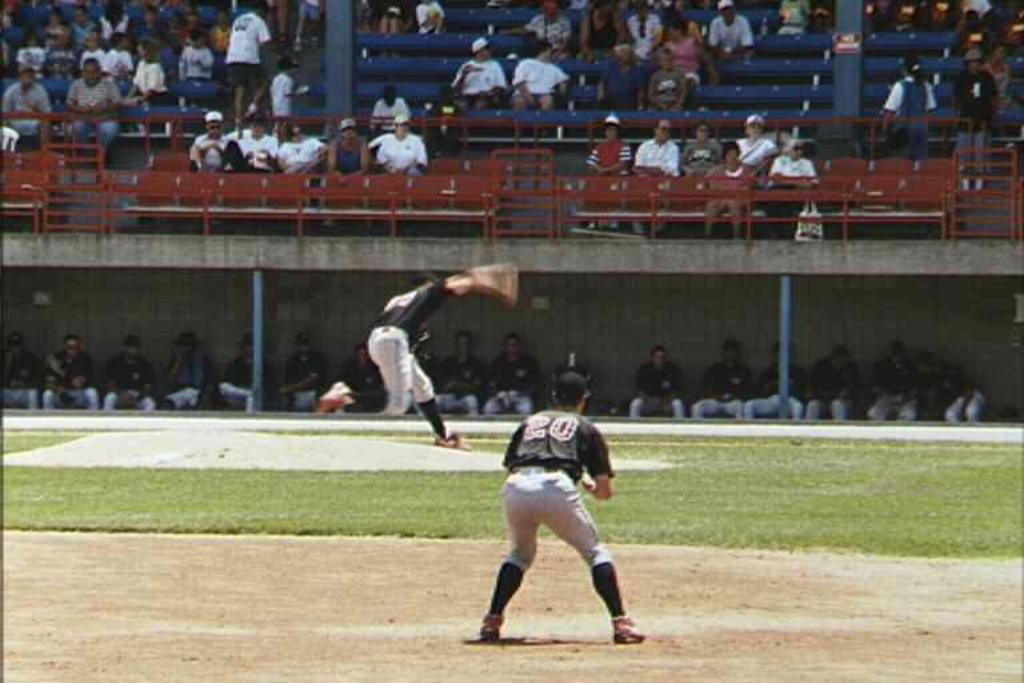<image>
Offer a succinct explanation of the picture presented. A man in a 20 jersey prepares on a baseball field. 